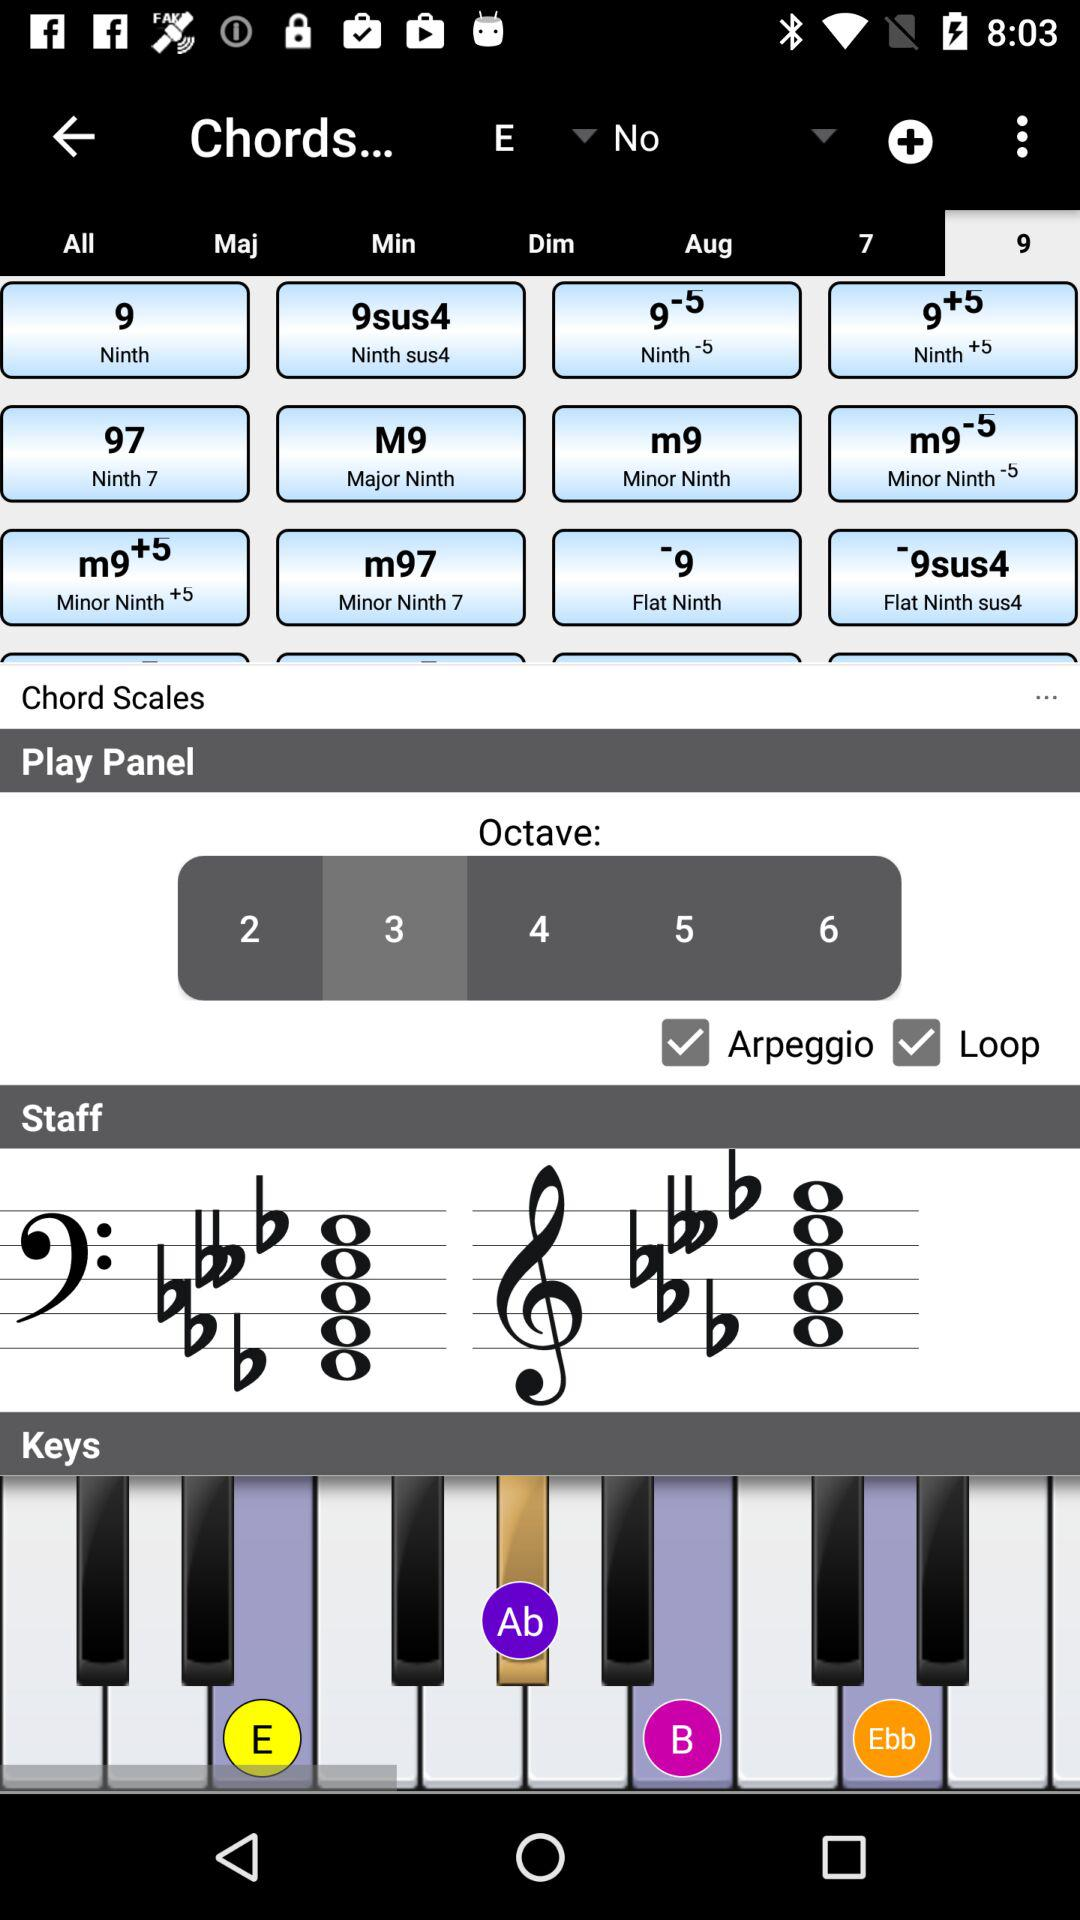Which octave number is selected in "Play Panel"? The selected octave number in "Play Panel" is 3. 